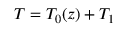Convert formula to latex. <formula><loc_0><loc_0><loc_500><loc_500>T = T _ { 0 } ( z ) + T _ { 1 }</formula> 